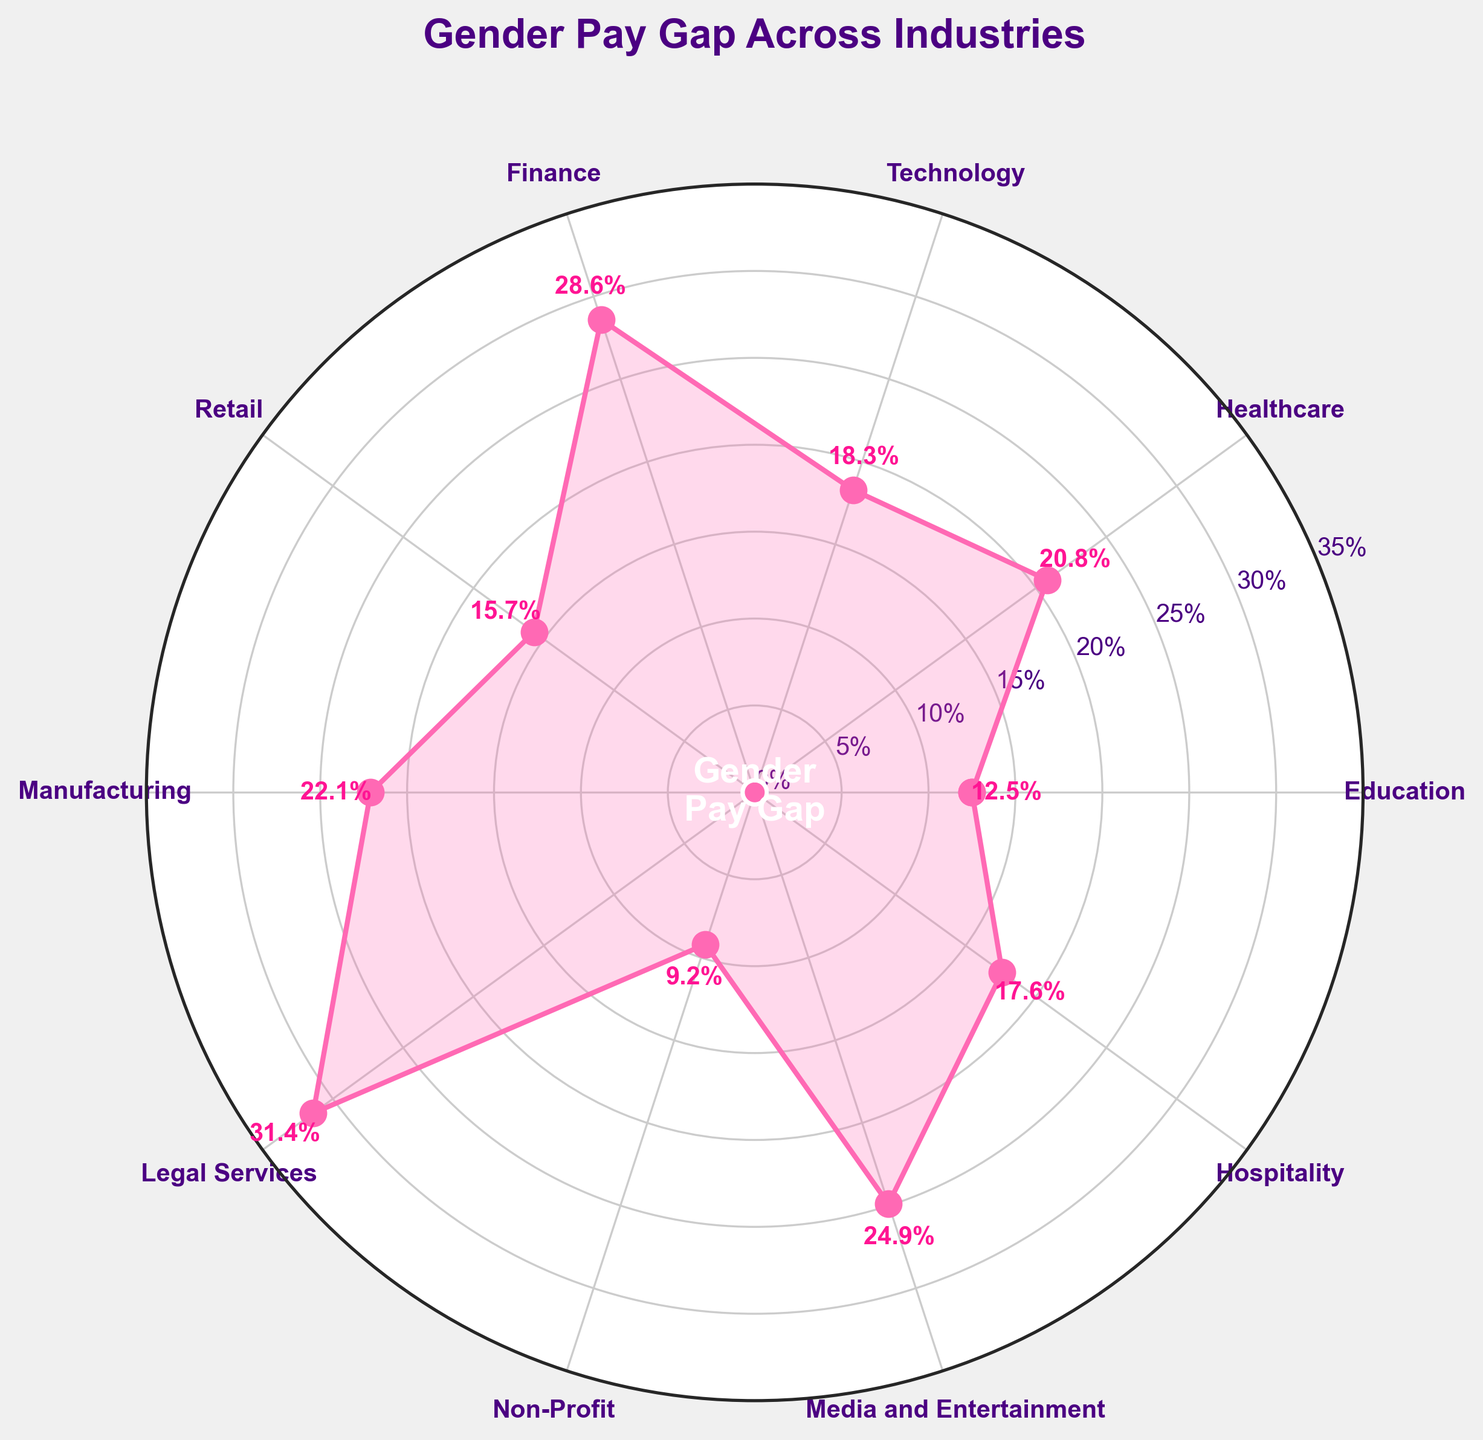How many industries are represented in the figure? There are labels placed around the circular plot for each industry. By counting these labels, we can determine the number of industries.
Answer: 10 What is the title of the figure? The title is prominently displayed above the circular plot.
Answer: Gender Pay Gap Across Industries Which industry has the highest gender pay gap percentage? Each industry's percentage is labeled outside the circle. Identify the highest percentage.
Answer: Legal Services What is the gender pay gap percentage in the Non-Profit industry? Find the label for Non-Profit and read the value next to it.
Answer: 9.2% Which two industries have the smallest and largest gender pay gap percentages? Compare all the labeled percentages to identify the smallest and largest values.
Answer: Smallest: Non-Profit, Largest: Legal Services What is the median gender pay gap percentage across all industries? Sort the percentages (9.2, 12.5, 15.7, 17.6, 18.3, 20.8, 22.1, 24.9, 28.6, 31.4). The median is the middle value.
Answer: 18.95% How much higher is the gender pay gap in Finance compared to Retail? Subtract the percentage for Retail from that of Finance: 28.6 - 15.7.
Answer: 12.9% Which industry has the closest gender pay gap percentage to 20%? Compare the percentages for each industry to 20%.
Answer: Healthcare Are there any industries with a gender pay gap percentage below 10%? If yes, which ones? Check each percentage and identify values below 10%.
Answer: Yes, Non-Profit 